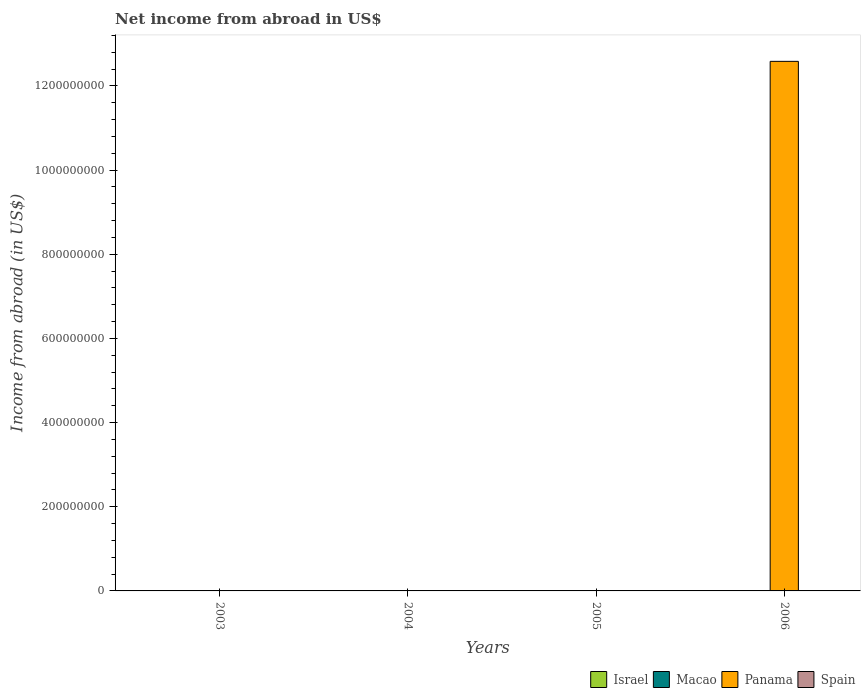How many different coloured bars are there?
Provide a succinct answer. 1. Are the number of bars per tick equal to the number of legend labels?
Provide a short and direct response. No. How many bars are there on the 3rd tick from the right?
Provide a succinct answer. 0. What is the net income from abroad in Israel in 2005?
Ensure brevity in your answer.  0. Across all years, what is the maximum net income from abroad in Panama?
Offer a very short reply. 1.26e+09. Across all years, what is the minimum net income from abroad in Macao?
Your answer should be very brief. 0. What is the total net income from abroad in Israel in the graph?
Offer a terse response. 0. What is the difference between the net income from abroad in Israel in 2003 and the net income from abroad in Panama in 2006?
Your answer should be very brief. -1.26e+09. In how many years, is the net income from abroad in Spain greater than the average net income from abroad in Spain taken over all years?
Make the answer very short. 0. How many bars are there?
Provide a succinct answer. 1. Are all the bars in the graph horizontal?
Make the answer very short. No. How many years are there in the graph?
Offer a very short reply. 4. What is the difference between two consecutive major ticks on the Y-axis?
Your response must be concise. 2.00e+08. How many legend labels are there?
Offer a terse response. 4. How are the legend labels stacked?
Keep it short and to the point. Horizontal. What is the title of the graph?
Make the answer very short. Net income from abroad in US$. Does "Northern Mariana Islands" appear as one of the legend labels in the graph?
Make the answer very short. No. What is the label or title of the Y-axis?
Your answer should be compact. Income from abroad (in US$). What is the Income from abroad (in US$) of Panama in 2003?
Give a very brief answer. 0. What is the Income from abroad (in US$) of Panama in 2004?
Provide a succinct answer. 0. What is the Income from abroad (in US$) of Panama in 2005?
Provide a short and direct response. 0. What is the Income from abroad (in US$) of Spain in 2005?
Make the answer very short. 0. What is the Income from abroad (in US$) of Panama in 2006?
Provide a short and direct response. 1.26e+09. Across all years, what is the maximum Income from abroad (in US$) of Panama?
Keep it short and to the point. 1.26e+09. What is the total Income from abroad (in US$) in Israel in the graph?
Ensure brevity in your answer.  0. What is the total Income from abroad (in US$) in Panama in the graph?
Your answer should be compact. 1.26e+09. What is the total Income from abroad (in US$) in Spain in the graph?
Give a very brief answer. 0. What is the average Income from abroad (in US$) of Macao per year?
Provide a succinct answer. 0. What is the average Income from abroad (in US$) of Panama per year?
Your answer should be compact. 3.15e+08. What is the average Income from abroad (in US$) of Spain per year?
Offer a terse response. 0. What is the difference between the highest and the lowest Income from abroad (in US$) in Panama?
Your response must be concise. 1.26e+09. 